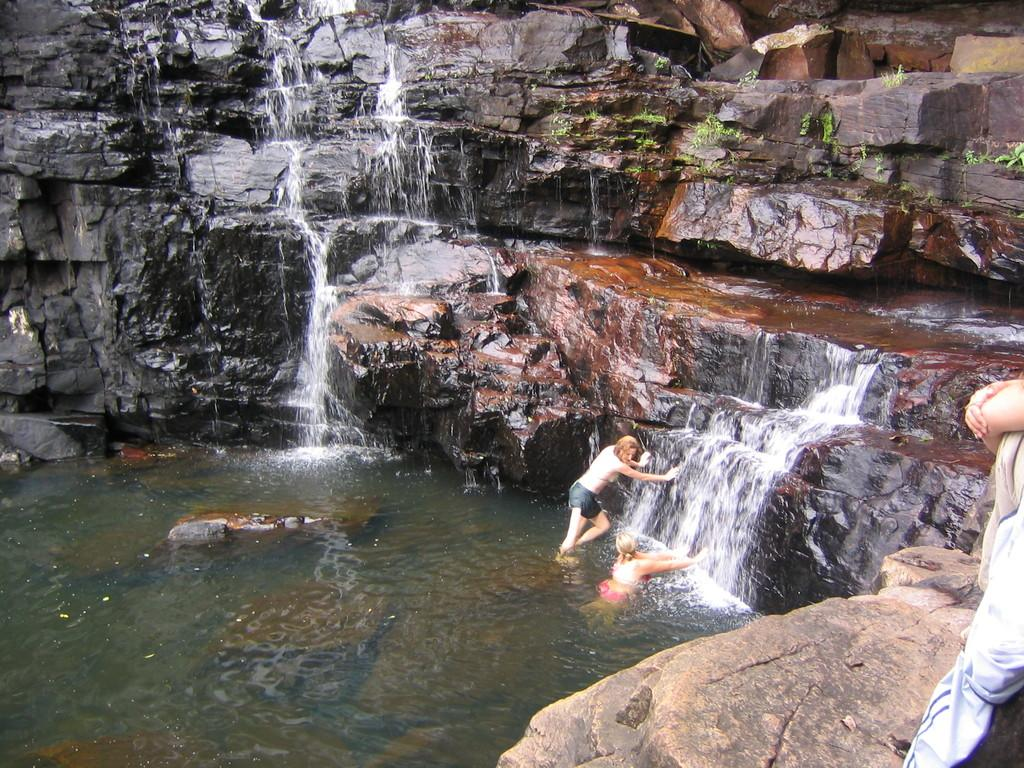What type of natural elements can be seen in the image? There are rocks and water visible in the image. How many people are present in the image? There are two women and one person in the image. Can you describe the setting of the image? The image features a natural environment with rocks and water. What type of agreement is being signed by the person in the image? There is no indication of a person signing an agreement in the image. What color is the cork used to seal the bottle in the image? There is no bottle or cork present in the image. 